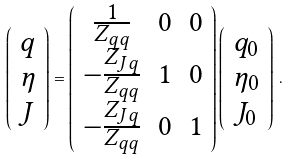Convert formula to latex. <formula><loc_0><loc_0><loc_500><loc_500>\left ( \begin{array} { c } q \\ \eta \\ J \end{array} \right ) = \left ( \begin{array} { c c c } \frac { 1 } { Z _ { q q } } & 0 & 0 \\ - \frac { Z _ { J q } } { Z _ { q q } } & 1 & 0 \\ - \frac { Z _ { J q } } { Z _ { q q } } & 0 & 1 \end{array} \right ) \left ( \begin{array} { c } q _ { 0 } \\ \eta _ { 0 } \\ J _ { 0 } \end{array} \right ) \, .</formula> 